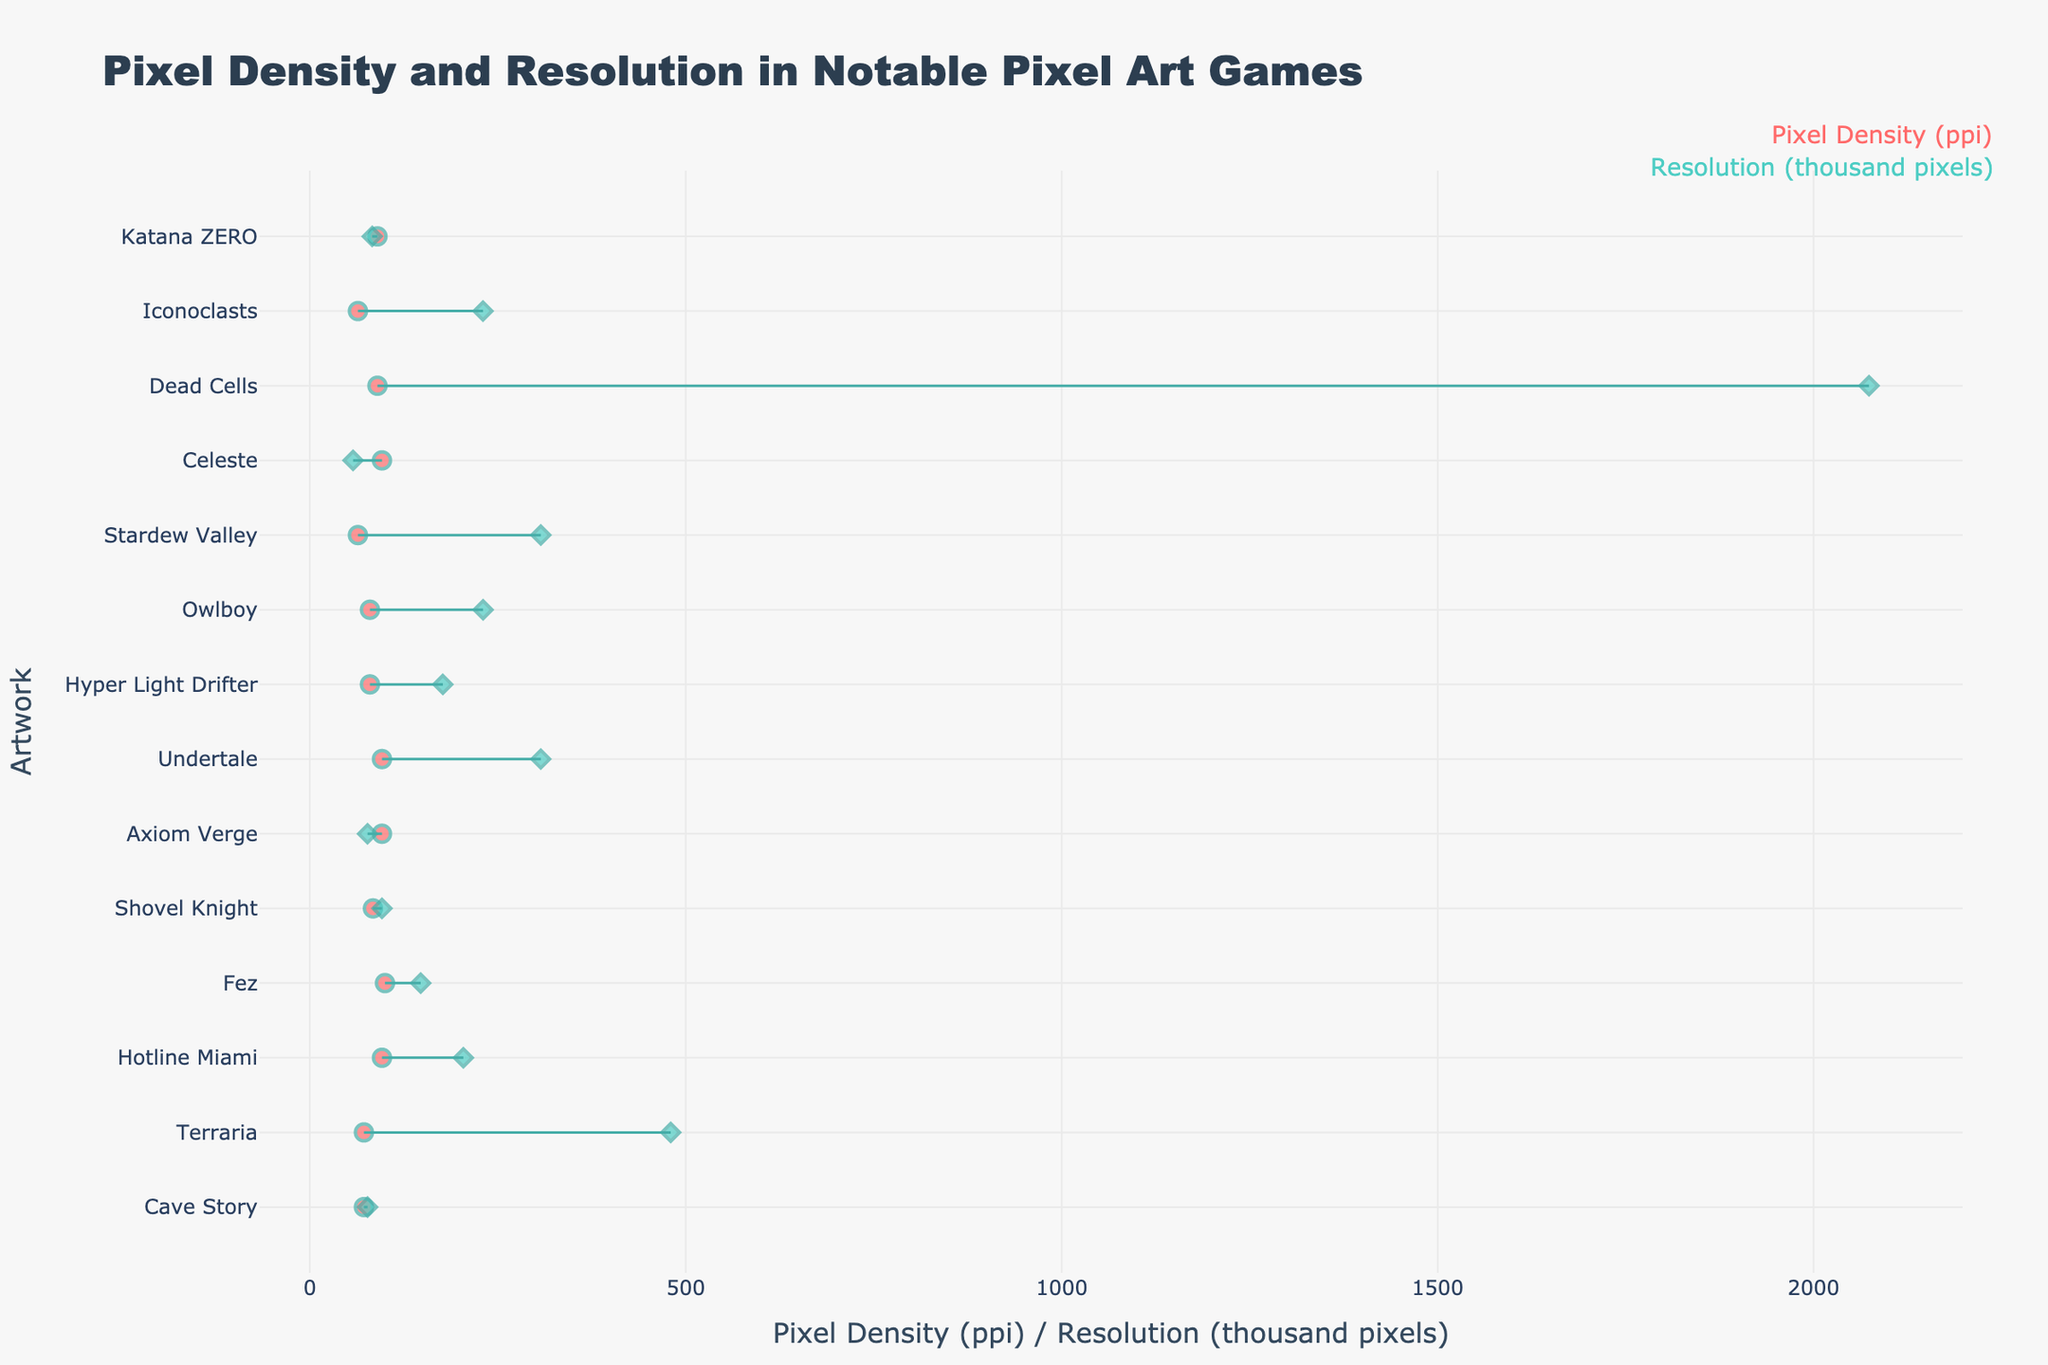What's the pixel density of Cave Story? The figure shows a data point labeled "Cave Story" with the x-axis representing pixel density and resolution. The pixel density value for Cave Story is indicated at this point.
Answer: 72 ppi Which artwork has the highest resolution in thousand pixels? The resolution in thousand pixels is calculated by multiplying the width and height of each artwork's resolution and then dividing by 1000. Comparing all artworks, Dead Cells has the highest resolution in thousand pixels (1920*1080/1000 = 2073.6).
Answer: Dead Cells What's the difference in pixel density between Shovel Knight and Stardew Valley? Shovel Knight has a pixel density indicated directly by one of the markers for the artwork, and so does Stardew Valley. Subtract the pixel density of Stardew Valley from that of Shovel Knight to find the difference.
Answer: 84 - 64 = 20 ppi Which artwork has a higher pixel density, Celeste or Axiom Verge? Check the pixel density values directly shown for Celeste and Axiom Verge on the x-axis. Celeste and Axiom Verge have the same pixel density.
Answer: Equal (96 ppi) What is the median pixel density of all the artworks? List all the pixel density values: 72, 96, 84, 96, 80, 100, 90, 90, 80, 64, 72, 96, 64. First, sort these values: 64, 64, 72, 72, 80, 80, 84, 90, 90, 96, 96, 96, 100. The median value is the middle number in this sorted list, which is 84.
Answer: 84 ppi Which artwork spans the greatest distance between pixel density and resolution when plotted? To determine the span, find the distance between the pixel density and resolution values along the x-axis for each artwork. The artwork with the largest difference between these values will have the greatest span. Dead Cells has the greatest distance due to its high resolution value.
Answer: Dead Cells Is Hyper Light Drifter’s resolution higher than Celeste’s? The resolution of Hyper Light Drifter can be calculated (560*316/1000) and compared with Celeste’s resolution (320*180/1000). Both converts to 177.28 and 57.6 thousand pixels respectively. Hyper Light Drifter has a higher resolution.
Answer: Yes What was the pixel density evolution from 2012 to 2015? Check the pixel densities for artworks created between 2012 and 2015: Hotline Miami (96), Fez (100), and Axiom Verge and Undertale (both 96). There is no clear increasing or decreasing trend. Pixel densities hovered around 96-100 ppi.
Answer: Around 96-100 ppi Among the games from 2014 to 2016, which one has the lowest pixel density? List the pixel densities for games from these years: Shovel Knight (84), Hyper Light Drifter (80), Owlboy (80), and Axiom Verge (96). The lowest value is one of Hyper Light Drifter and Owlboy (both 80 ppi).
Answer: Hyper Light Drifter and Owlboy (both 80 ppi) 